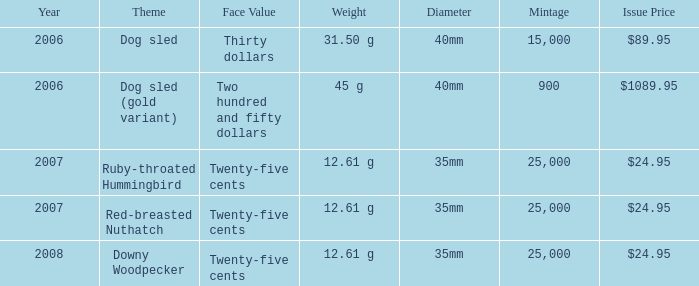What is the diameter of the gold variant dog sled theme coin? 40mm. Parse the full table. {'header': ['Year', 'Theme', 'Face Value', 'Weight', 'Diameter', 'Mintage', 'Issue Price'], 'rows': [['2006', 'Dog sled', 'Thirty dollars', '31.50 g', '40mm', '15,000', '$89.95'], ['2006', 'Dog sled (gold variant)', 'Two hundred and fifty dollars', '45 g', '40mm', '900', '$1089.95'], ['2007', 'Ruby-throated Hummingbird', 'Twenty-five cents', '12.61 g', '35mm', '25,000', '$24.95'], ['2007', 'Red-breasted Nuthatch', 'Twenty-five cents', '12.61 g', '35mm', '25,000', '$24.95'], ['2008', 'Downy Woodpecker', 'Twenty-five cents', '12.61 g', '35mm', '25,000', '$24.95']]} 